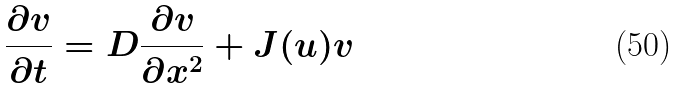<formula> <loc_0><loc_0><loc_500><loc_500>\frac { \partial v } { \partial t } = D \frac { \partial v } { \partial x ^ { 2 } } + J ( u ) v</formula> 